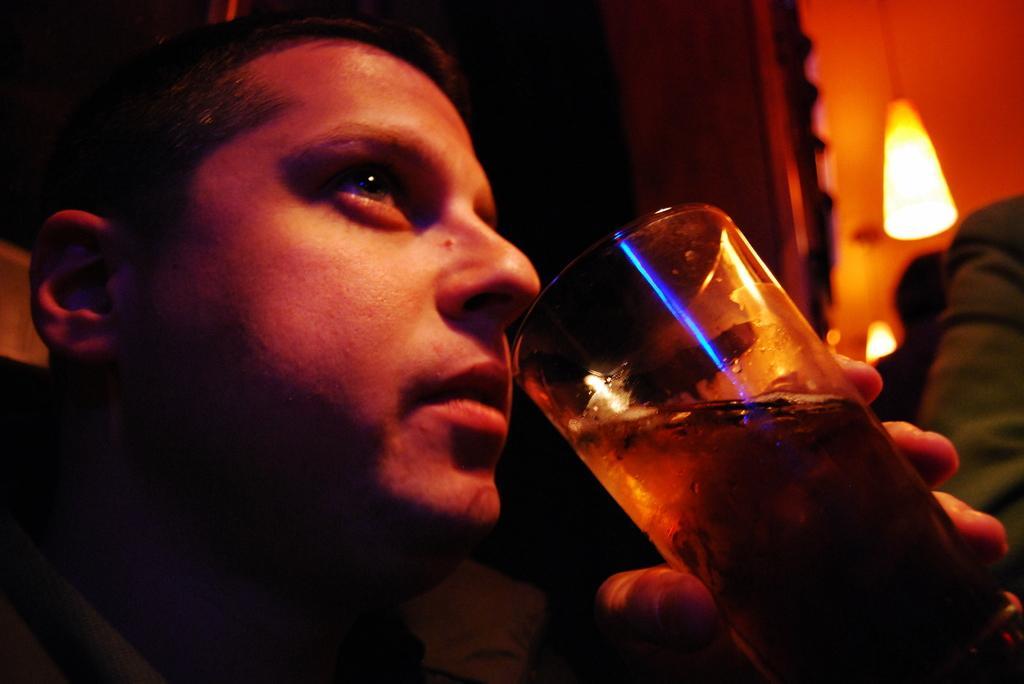Describe this image in one or two sentences. In the foreground of this image, there is a man holding a glass. In the dark background, there is a light hanging to the ceiling and there are two persons. 